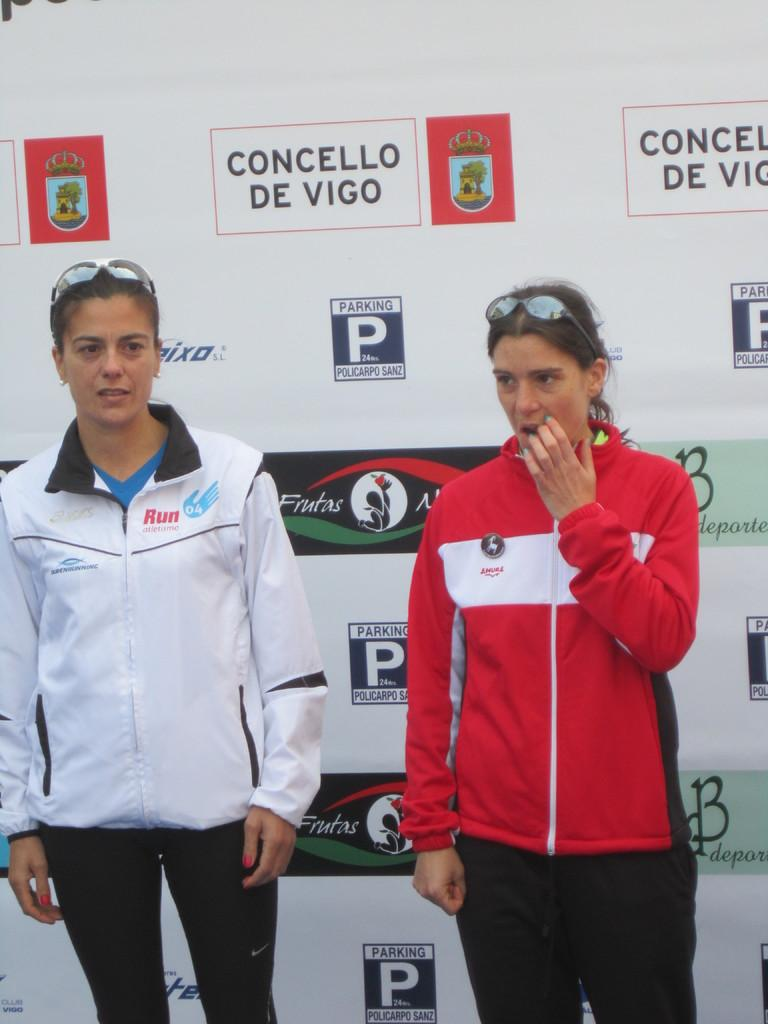<image>
Present a compact description of the photo's key features. Two women are standing in front a wall with the logo for concello de vigo. 